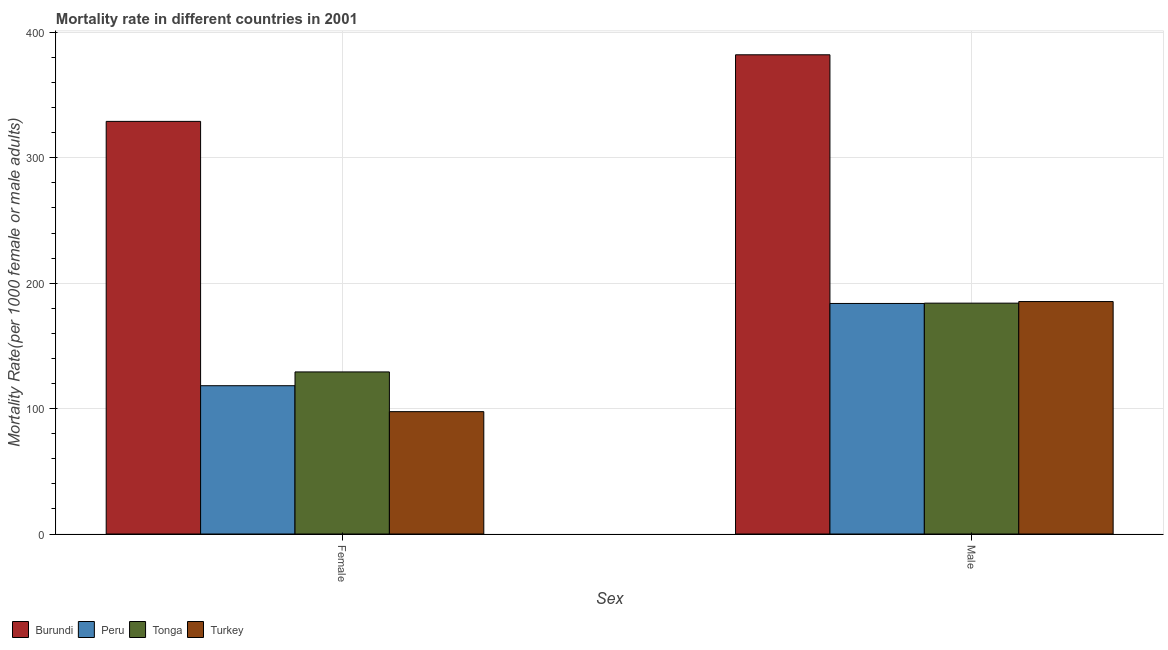How many different coloured bars are there?
Your response must be concise. 4. What is the male mortality rate in Peru?
Ensure brevity in your answer.  183.85. Across all countries, what is the maximum male mortality rate?
Provide a succinct answer. 382.16. Across all countries, what is the minimum male mortality rate?
Ensure brevity in your answer.  183.85. In which country was the female mortality rate maximum?
Make the answer very short. Burundi. What is the total male mortality rate in the graph?
Give a very brief answer. 935.49. What is the difference between the female mortality rate in Peru and that in Burundi?
Ensure brevity in your answer.  -210.81. What is the difference between the female mortality rate in Peru and the male mortality rate in Burundi?
Provide a succinct answer. -263.91. What is the average female mortality rate per country?
Your answer should be compact. 168.54. What is the difference between the female mortality rate and male mortality rate in Turkey?
Offer a very short reply. -87.79. What is the ratio of the male mortality rate in Peru to that in Tonga?
Offer a terse response. 1. In how many countries, is the male mortality rate greater than the average male mortality rate taken over all countries?
Ensure brevity in your answer.  1. What does the 1st bar from the left in Female represents?
Offer a very short reply. Burundi. What does the 1st bar from the right in Male represents?
Ensure brevity in your answer.  Turkey. How many bars are there?
Provide a short and direct response. 8. Are all the bars in the graph horizontal?
Ensure brevity in your answer.  No. How many countries are there in the graph?
Ensure brevity in your answer.  4. Does the graph contain any zero values?
Give a very brief answer. No. What is the title of the graph?
Provide a short and direct response. Mortality rate in different countries in 2001. What is the label or title of the X-axis?
Your answer should be very brief. Sex. What is the label or title of the Y-axis?
Offer a very short reply. Mortality Rate(per 1000 female or male adults). What is the Mortality Rate(per 1000 female or male adults) in Burundi in Female?
Your response must be concise. 329.06. What is the Mortality Rate(per 1000 female or male adults) in Peru in Female?
Offer a very short reply. 118.25. What is the Mortality Rate(per 1000 female or male adults) in Tonga in Female?
Give a very brief answer. 129.25. What is the Mortality Rate(per 1000 female or male adults) of Turkey in Female?
Offer a terse response. 97.58. What is the Mortality Rate(per 1000 female or male adults) of Burundi in Male?
Provide a succinct answer. 382.16. What is the Mortality Rate(per 1000 female or male adults) of Peru in Male?
Offer a terse response. 183.85. What is the Mortality Rate(per 1000 female or male adults) in Tonga in Male?
Keep it short and to the point. 184.1. What is the Mortality Rate(per 1000 female or male adults) in Turkey in Male?
Give a very brief answer. 185.37. Across all Sex, what is the maximum Mortality Rate(per 1000 female or male adults) in Burundi?
Offer a very short reply. 382.16. Across all Sex, what is the maximum Mortality Rate(per 1000 female or male adults) of Peru?
Provide a short and direct response. 183.85. Across all Sex, what is the maximum Mortality Rate(per 1000 female or male adults) of Tonga?
Provide a succinct answer. 184.1. Across all Sex, what is the maximum Mortality Rate(per 1000 female or male adults) of Turkey?
Give a very brief answer. 185.37. Across all Sex, what is the minimum Mortality Rate(per 1000 female or male adults) of Burundi?
Provide a succinct answer. 329.06. Across all Sex, what is the minimum Mortality Rate(per 1000 female or male adults) in Peru?
Your answer should be compact. 118.25. Across all Sex, what is the minimum Mortality Rate(per 1000 female or male adults) in Tonga?
Keep it short and to the point. 129.25. Across all Sex, what is the minimum Mortality Rate(per 1000 female or male adults) of Turkey?
Your answer should be very brief. 97.58. What is the total Mortality Rate(per 1000 female or male adults) in Burundi in the graph?
Your response must be concise. 711.22. What is the total Mortality Rate(per 1000 female or male adults) in Peru in the graph?
Give a very brief answer. 302.11. What is the total Mortality Rate(per 1000 female or male adults) in Tonga in the graph?
Provide a short and direct response. 313.35. What is the total Mortality Rate(per 1000 female or male adults) of Turkey in the graph?
Give a very brief answer. 282.95. What is the difference between the Mortality Rate(per 1000 female or male adults) of Burundi in Female and that in Male?
Your answer should be very brief. -53.1. What is the difference between the Mortality Rate(per 1000 female or male adults) in Peru in Female and that in Male?
Provide a short and direct response. -65.6. What is the difference between the Mortality Rate(per 1000 female or male adults) in Tonga in Female and that in Male?
Your answer should be compact. -54.84. What is the difference between the Mortality Rate(per 1000 female or male adults) in Turkey in Female and that in Male?
Offer a terse response. -87.79. What is the difference between the Mortality Rate(per 1000 female or male adults) in Burundi in Female and the Mortality Rate(per 1000 female or male adults) in Peru in Male?
Ensure brevity in your answer.  145.21. What is the difference between the Mortality Rate(per 1000 female or male adults) in Burundi in Female and the Mortality Rate(per 1000 female or male adults) in Tonga in Male?
Keep it short and to the point. 144.96. What is the difference between the Mortality Rate(per 1000 female or male adults) of Burundi in Female and the Mortality Rate(per 1000 female or male adults) of Turkey in Male?
Provide a short and direct response. 143.69. What is the difference between the Mortality Rate(per 1000 female or male adults) in Peru in Female and the Mortality Rate(per 1000 female or male adults) in Tonga in Male?
Provide a succinct answer. -65.84. What is the difference between the Mortality Rate(per 1000 female or male adults) in Peru in Female and the Mortality Rate(per 1000 female or male adults) in Turkey in Male?
Keep it short and to the point. -67.12. What is the difference between the Mortality Rate(per 1000 female or male adults) of Tonga in Female and the Mortality Rate(per 1000 female or male adults) of Turkey in Male?
Give a very brief answer. -56.11. What is the average Mortality Rate(per 1000 female or male adults) of Burundi per Sex?
Provide a succinct answer. 355.61. What is the average Mortality Rate(per 1000 female or male adults) in Peru per Sex?
Keep it short and to the point. 151.05. What is the average Mortality Rate(per 1000 female or male adults) of Tonga per Sex?
Provide a succinct answer. 156.68. What is the average Mortality Rate(per 1000 female or male adults) of Turkey per Sex?
Your response must be concise. 141.47. What is the difference between the Mortality Rate(per 1000 female or male adults) in Burundi and Mortality Rate(per 1000 female or male adults) in Peru in Female?
Keep it short and to the point. 210.81. What is the difference between the Mortality Rate(per 1000 female or male adults) of Burundi and Mortality Rate(per 1000 female or male adults) of Tonga in Female?
Give a very brief answer. 199.81. What is the difference between the Mortality Rate(per 1000 female or male adults) of Burundi and Mortality Rate(per 1000 female or male adults) of Turkey in Female?
Your answer should be compact. 231.48. What is the difference between the Mortality Rate(per 1000 female or male adults) in Peru and Mortality Rate(per 1000 female or male adults) in Tonga in Female?
Offer a very short reply. -11. What is the difference between the Mortality Rate(per 1000 female or male adults) in Peru and Mortality Rate(per 1000 female or male adults) in Turkey in Female?
Make the answer very short. 20.67. What is the difference between the Mortality Rate(per 1000 female or male adults) in Tonga and Mortality Rate(per 1000 female or male adults) in Turkey in Female?
Ensure brevity in your answer.  31.68. What is the difference between the Mortality Rate(per 1000 female or male adults) of Burundi and Mortality Rate(per 1000 female or male adults) of Peru in Male?
Offer a terse response. 198.31. What is the difference between the Mortality Rate(per 1000 female or male adults) in Burundi and Mortality Rate(per 1000 female or male adults) in Tonga in Male?
Your answer should be very brief. 198.07. What is the difference between the Mortality Rate(per 1000 female or male adults) in Burundi and Mortality Rate(per 1000 female or male adults) in Turkey in Male?
Make the answer very short. 196.79. What is the difference between the Mortality Rate(per 1000 female or male adults) in Peru and Mortality Rate(per 1000 female or male adults) in Tonga in Male?
Keep it short and to the point. -0.24. What is the difference between the Mortality Rate(per 1000 female or male adults) of Peru and Mortality Rate(per 1000 female or male adults) of Turkey in Male?
Your answer should be very brief. -1.51. What is the difference between the Mortality Rate(per 1000 female or male adults) in Tonga and Mortality Rate(per 1000 female or male adults) in Turkey in Male?
Provide a short and direct response. -1.27. What is the ratio of the Mortality Rate(per 1000 female or male adults) in Burundi in Female to that in Male?
Your answer should be compact. 0.86. What is the ratio of the Mortality Rate(per 1000 female or male adults) in Peru in Female to that in Male?
Provide a short and direct response. 0.64. What is the ratio of the Mortality Rate(per 1000 female or male adults) in Tonga in Female to that in Male?
Ensure brevity in your answer.  0.7. What is the ratio of the Mortality Rate(per 1000 female or male adults) in Turkey in Female to that in Male?
Make the answer very short. 0.53. What is the difference between the highest and the second highest Mortality Rate(per 1000 female or male adults) of Burundi?
Your answer should be compact. 53.1. What is the difference between the highest and the second highest Mortality Rate(per 1000 female or male adults) in Peru?
Offer a terse response. 65.6. What is the difference between the highest and the second highest Mortality Rate(per 1000 female or male adults) of Tonga?
Ensure brevity in your answer.  54.84. What is the difference between the highest and the second highest Mortality Rate(per 1000 female or male adults) in Turkey?
Your answer should be very brief. 87.79. What is the difference between the highest and the lowest Mortality Rate(per 1000 female or male adults) of Burundi?
Offer a very short reply. 53.1. What is the difference between the highest and the lowest Mortality Rate(per 1000 female or male adults) of Peru?
Your response must be concise. 65.6. What is the difference between the highest and the lowest Mortality Rate(per 1000 female or male adults) of Tonga?
Offer a very short reply. 54.84. What is the difference between the highest and the lowest Mortality Rate(per 1000 female or male adults) of Turkey?
Your answer should be compact. 87.79. 